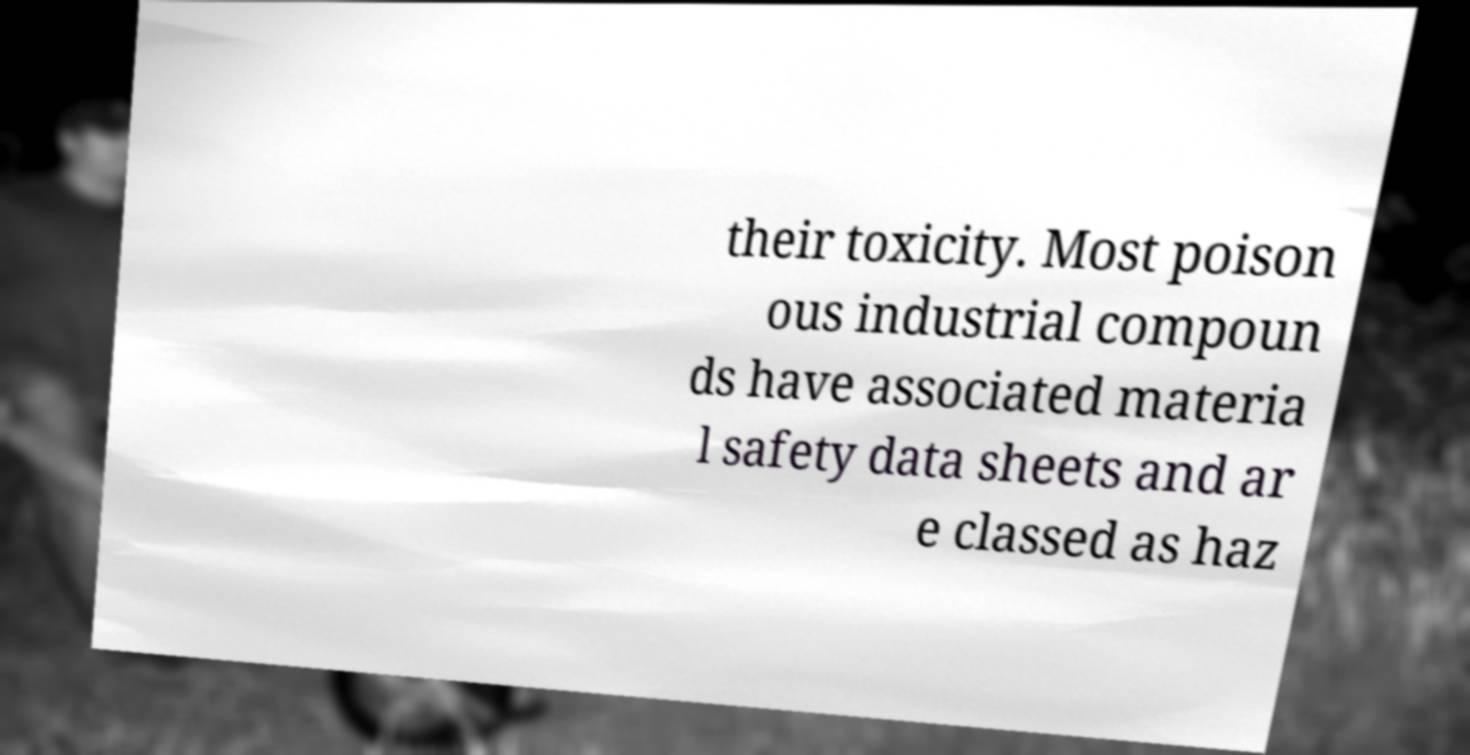I need the written content from this picture converted into text. Can you do that? their toxicity. Most poison ous industrial compoun ds have associated materia l safety data sheets and ar e classed as haz 